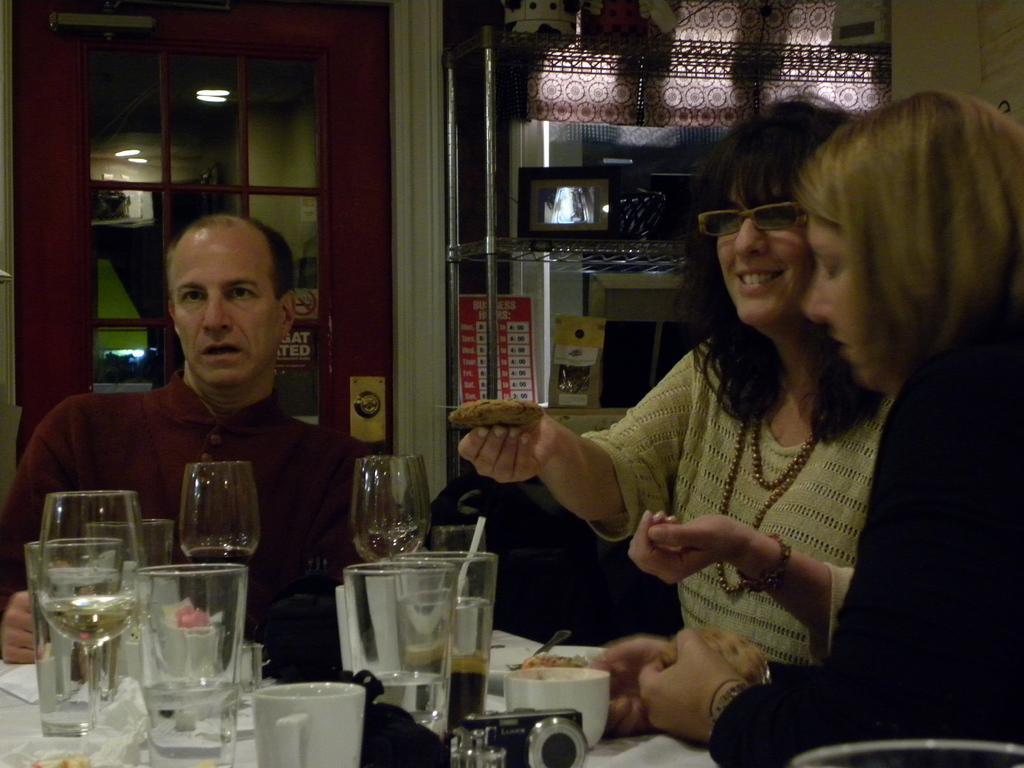In one or two sentences, can you explain what this image depicts? At the bottom of the image there is a table with glasses, cups, spoons, tissues and also there is a camera. On the right side of the image there is a person. Beside that person there is a lady with spectacles is sitting and holding a food item in her hand. Behind the table there is a man. Behind the man there is a glass door. On the right side of the image there is a cupboard with racks. On the racks there are many other items. 